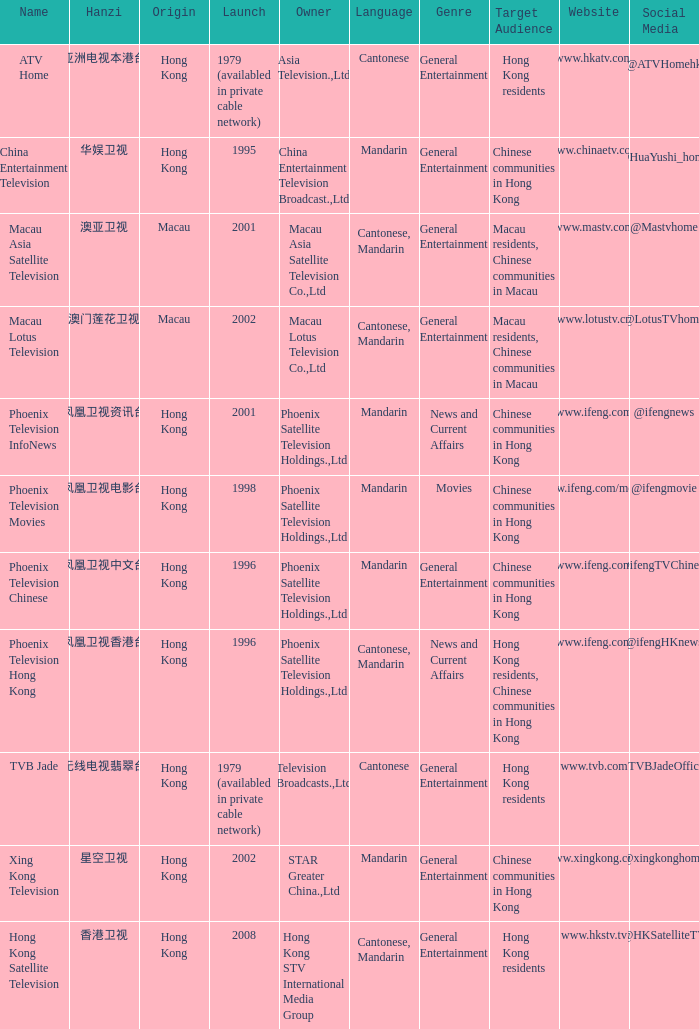What is the Hanzi of Hong Kong in 1998? 凤凰卫视电影台. 